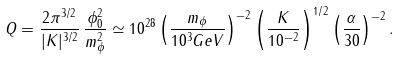Convert formula to latex. <formula><loc_0><loc_0><loc_500><loc_500>Q = \frac { 2 \pi ^ { 3 / 2 } } { | K | ^ { 3 / 2 } } \, \frac { \phi _ { 0 } ^ { 2 } } { m _ { \phi } ^ { 2 } } \simeq 1 0 ^ { 2 8 } \left ( \frac { m _ { \phi } } { 1 0 ^ { 3 } G e V } \right ) ^ { - 2 } \left ( \frac { K } { 1 0 ^ { - 2 } } \right ) ^ { 1 / 2 } \left ( \frac { \alpha } { 3 0 } \right ) ^ { - 2 } .</formula> 